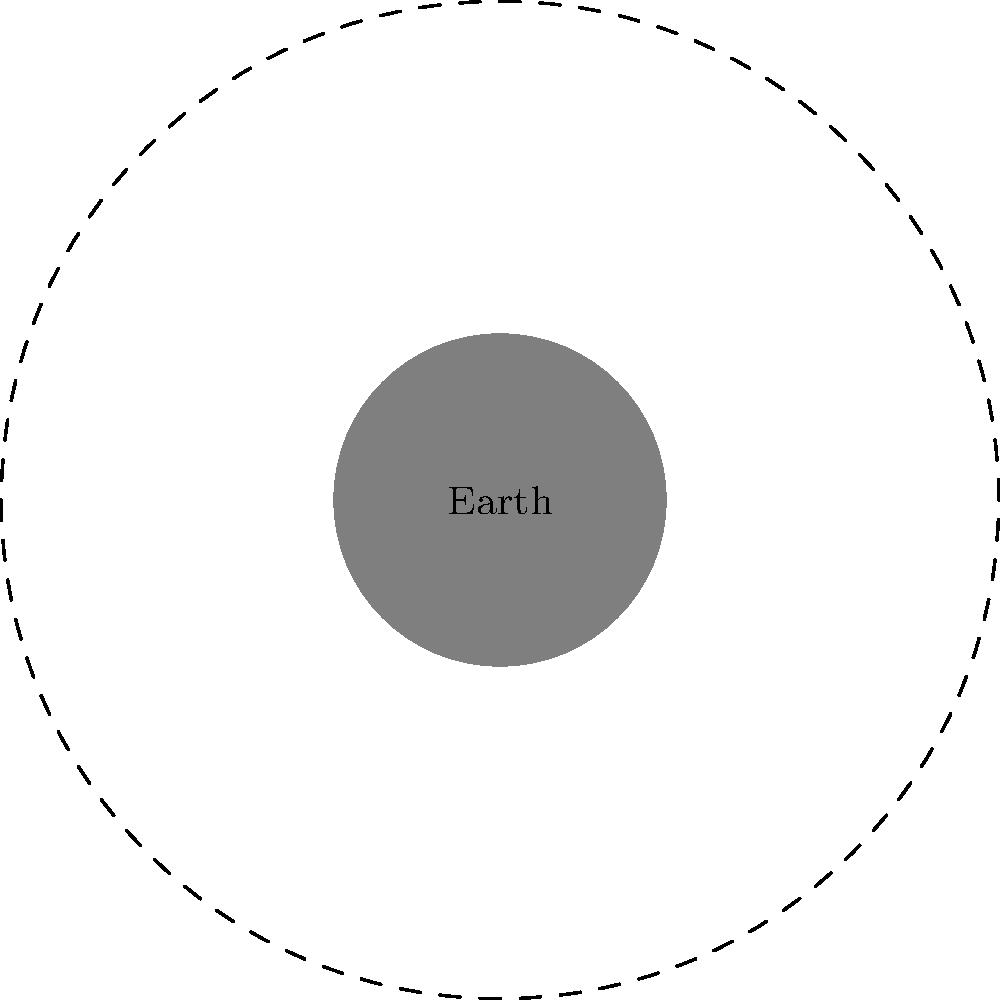As a customs officer accustomed to observing details, you've noticed the moon's appearance changing over time. Which phase of the moon would be most useful for conducting night patrols along the border, and why? To answer this question, let's analyze the moon phases and their implications for night visibility:

1. New Moon: The moon is not visible from Earth, as its unilluminated side faces us.
2. Waxing Crescent: A small portion of the moon is visible, increasing each night.
3. First Quarter: Half of the moon's visible surface is illuminated.
4. Waxing Gibbous: More than half of the moon is illuminated, approaching full moon.
5. Full Moon: The entire visible surface of the moon is illuminated.
6. Waning Gibbous: More than half of the moon is illuminated, decreasing from full moon.
7. Third Quarter: Half of the moon's visible surface is illuminated, opposite to first quarter.
8. Waning Crescent: A small portion of the moon is visible, decreasing each night.

For night patrols, the ideal phase would be the Full Moon because:

a) It provides maximum illumination, improving visibility during night operations.
b) The full moon rises at sunset and sets at sunrise, offering light throughout the night.
c) Enhanced visibility can aid in detecting suspicious activities or movement along the border.
d) It reduces the need for artificial lighting, potentially making patrols less conspicuous.

However, it's important to note that while the full moon offers the most light, it can also make patrolling officers more visible to potential criminals. Therefore, tactical considerations should be taken into account when planning patrols during this phase.
Answer: Full Moon 